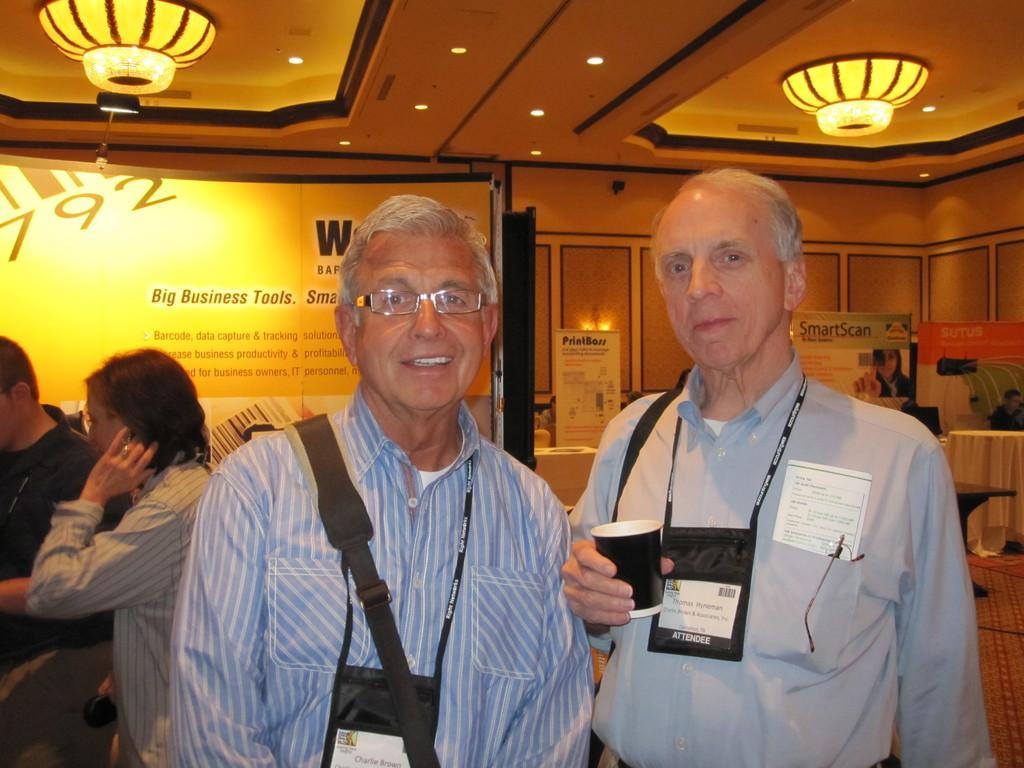In one or two sentences, can you explain what this image depicts? In this image I can see in the middle two men are standing, they wore shirts and Id cards. At the top there are ceiling lights. 